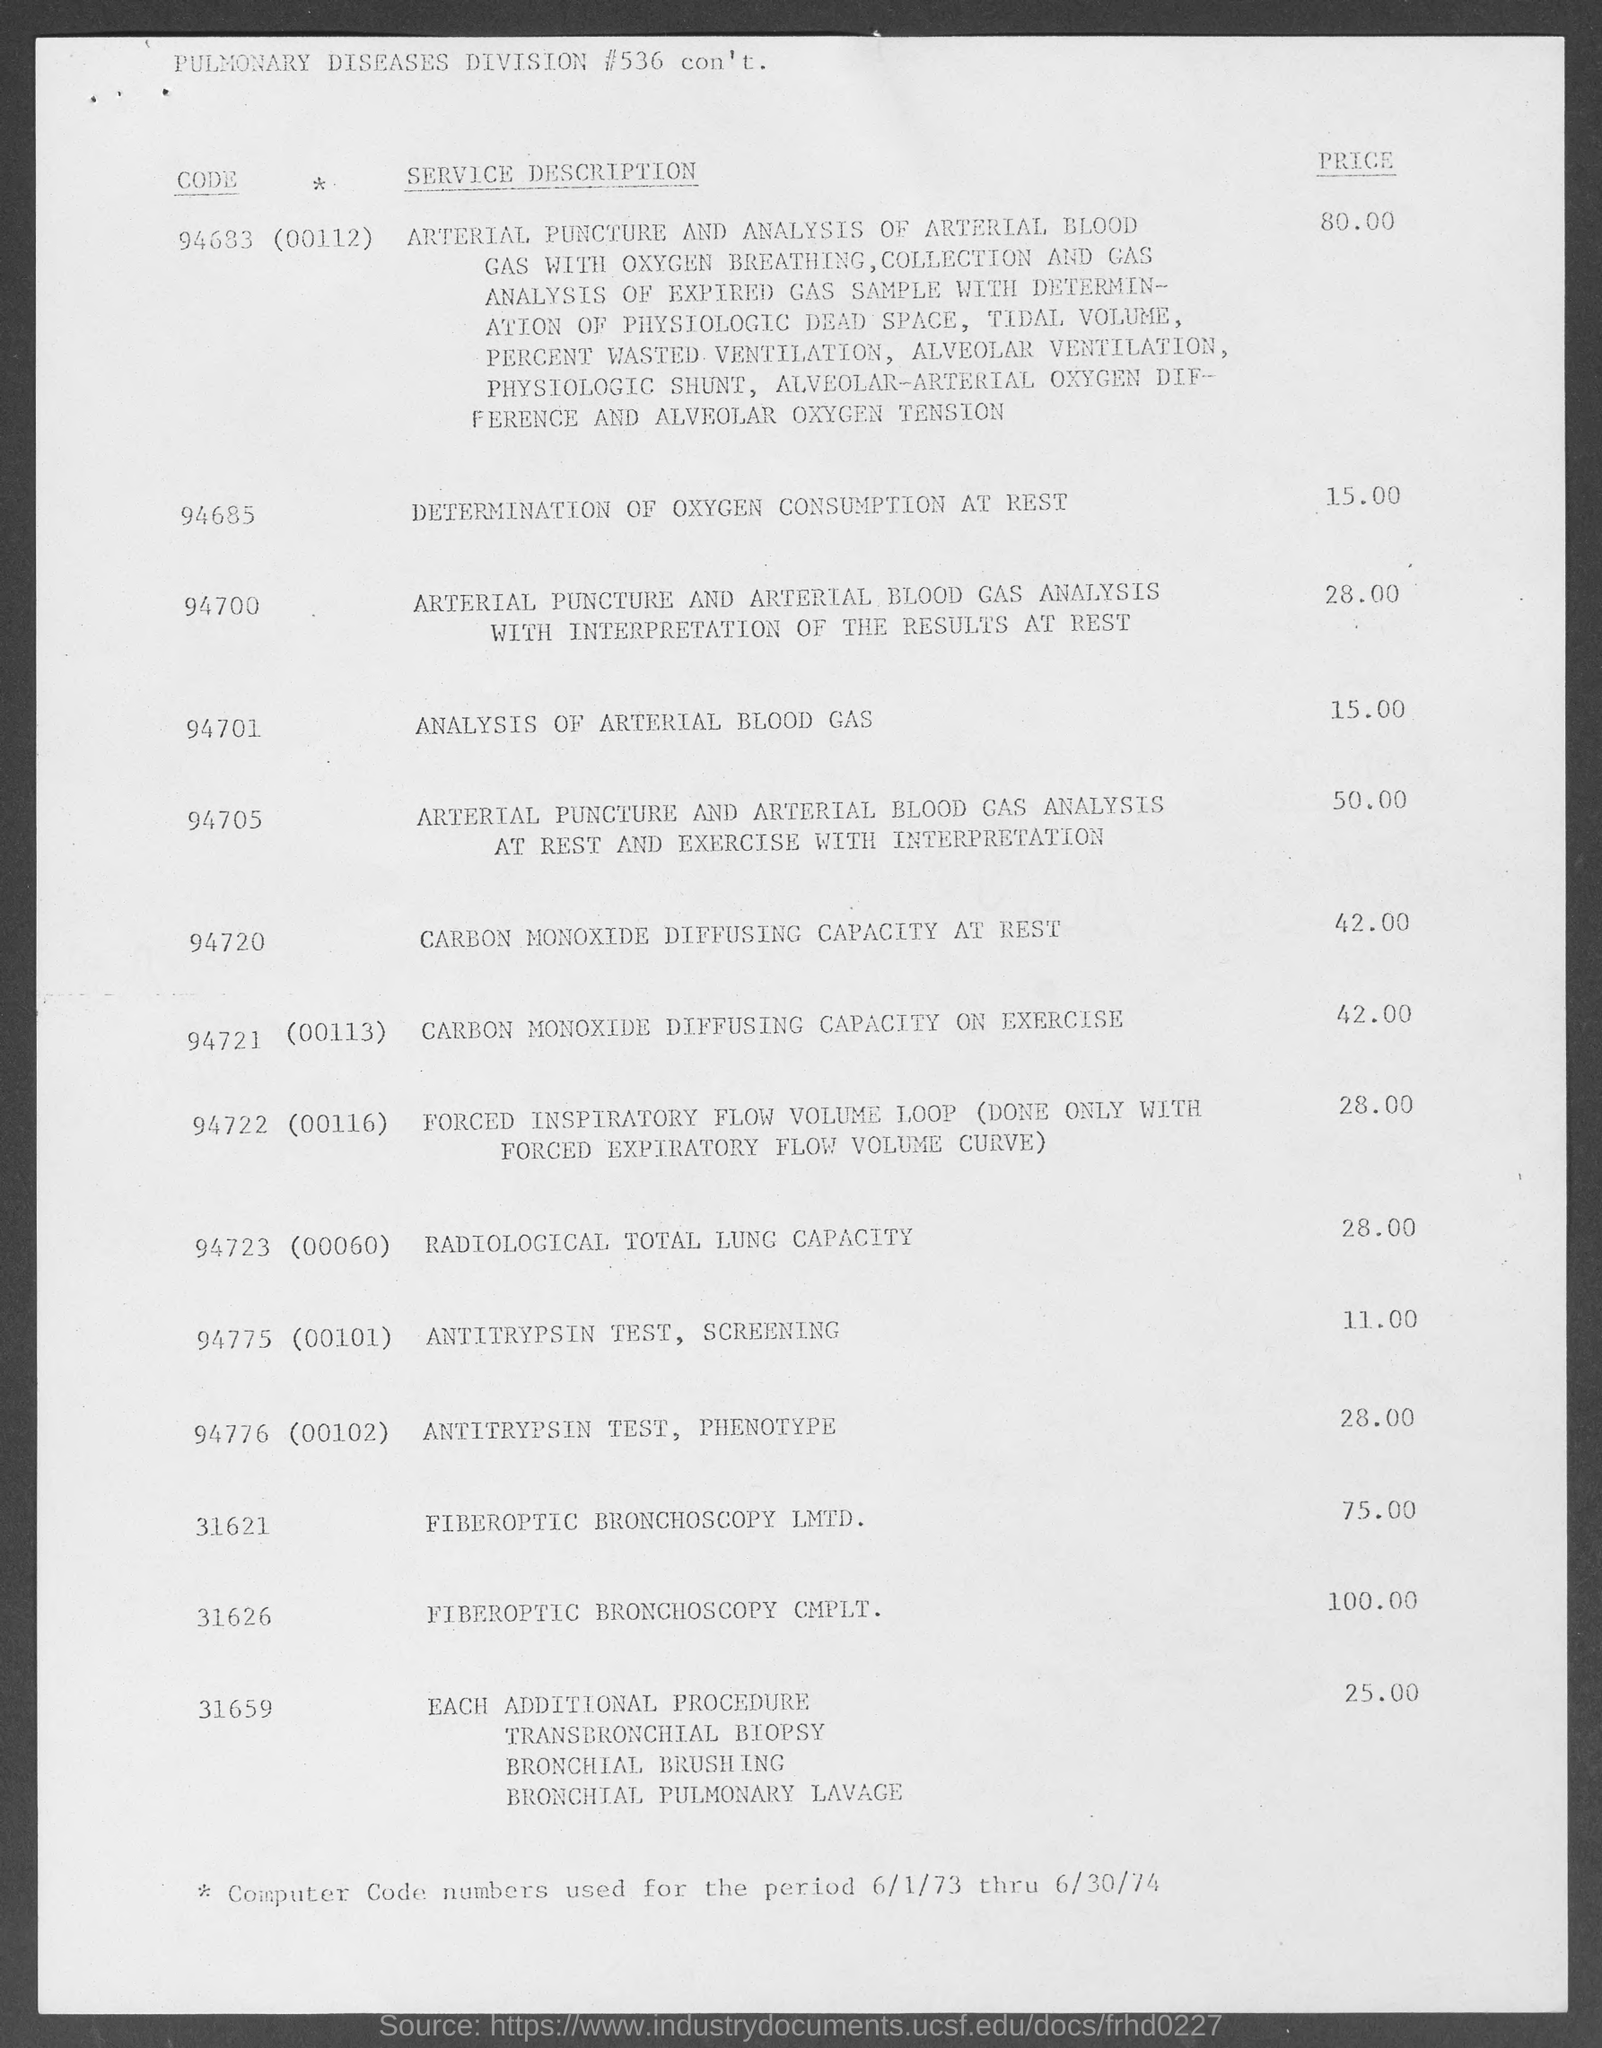What is the code for DETERMINATION OF OXYGEN CONSUMPTION AT REST?
Your response must be concise. 94685. What is the price of ANALYSIS OF ARTERIAL BLOOD GAS?
Ensure brevity in your answer.  15. What is the code of RADIOLOGICAL TOTAL LUNG CAPACITY?
Give a very brief answer. 94723(00060). 